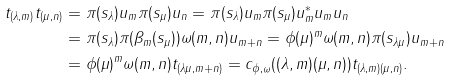Convert formula to latex. <formula><loc_0><loc_0><loc_500><loc_500>t _ { ( \lambda , m ) } t _ { ( \mu , n ) } & = \pi ( s _ { \lambda } ) u _ { m } \pi ( s _ { \mu } ) u _ { n } = \pi ( s _ { \lambda } ) u _ { m } \pi ( s _ { \mu } ) u ^ { * } _ { m } u _ { m } u _ { n } \\ & = \pi ( s _ { \lambda } ) \pi ( \beta _ { m } ( s _ { \mu } ) ) \omega ( m , n ) u _ { m + n } = \phi ( \mu ) ^ { m } \omega ( m , n ) \pi ( s _ { \lambda \mu } ) u _ { m + n } \\ & = \phi ( \mu ) ^ { m } \omega ( m , n ) t _ { ( \lambda \mu , m + n ) } = c _ { \phi , \omega } ( ( \lambda , m ) ( \mu , n ) ) t _ { ( \lambda , m ) ( \mu , n ) } .</formula> 